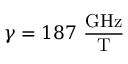<formula> <loc_0><loc_0><loc_500><loc_500>\gamma = 1 8 7 \frac { G H z } { T }</formula> 